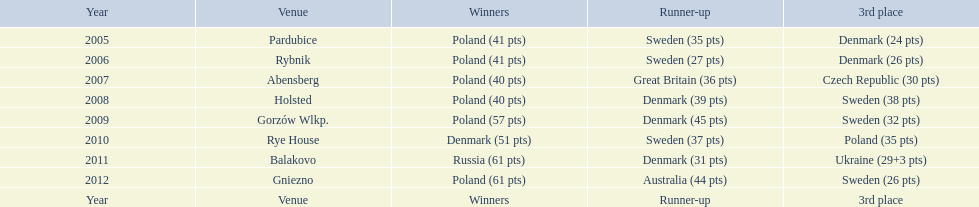After their first place win in 2009, how did poland place the next year at the speedway junior world championship? 3rd place. 